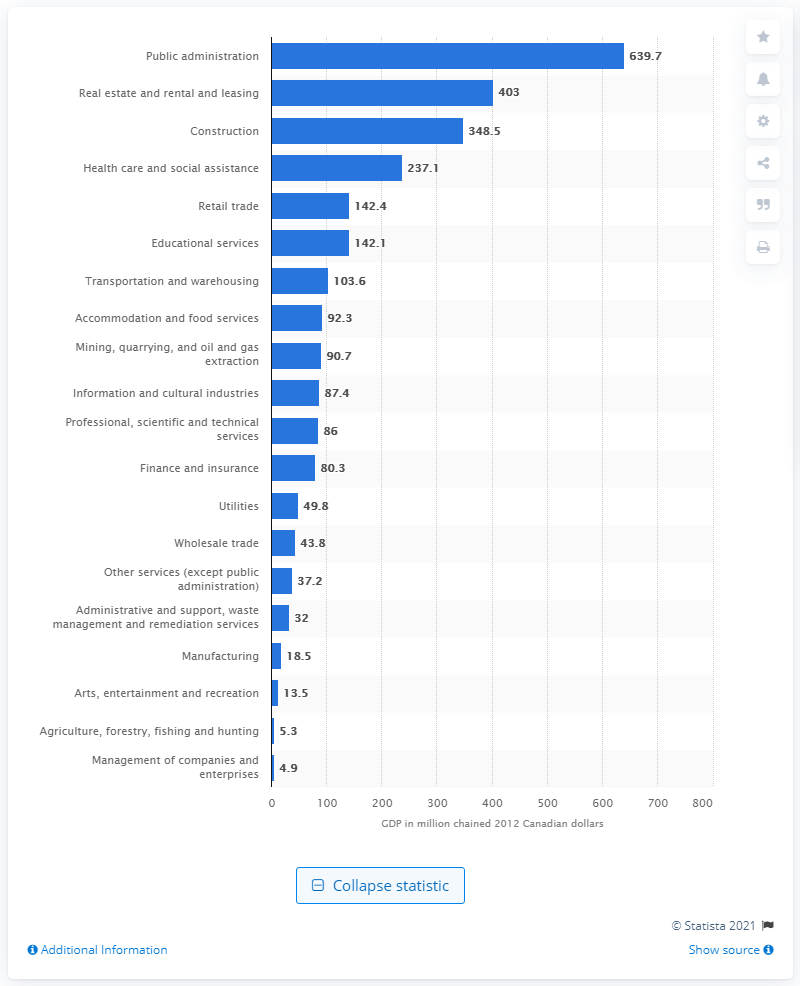Indicate a few pertinent items in this graphic. In 2012, the GDP of the construction industry in Yukon was approximately 348.5 Canadian dollars. 